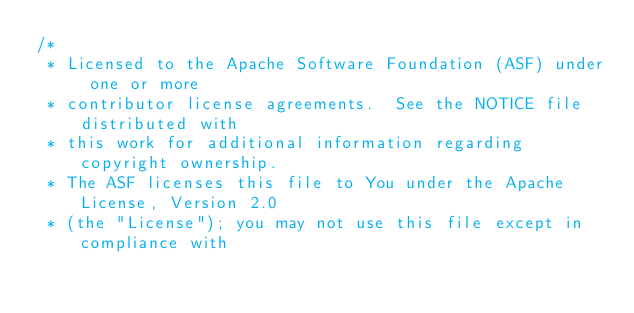<code> <loc_0><loc_0><loc_500><loc_500><_Scala_>/*
 * Licensed to the Apache Software Foundation (ASF) under one or more
 * contributor license agreements.  See the NOTICE file distributed with
 * this work for additional information regarding copyright ownership.
 * The ASF licenses this file to You under the Apache License, Version 2.0
 * (the "License"); you may not use this file except in compliance with</code> 